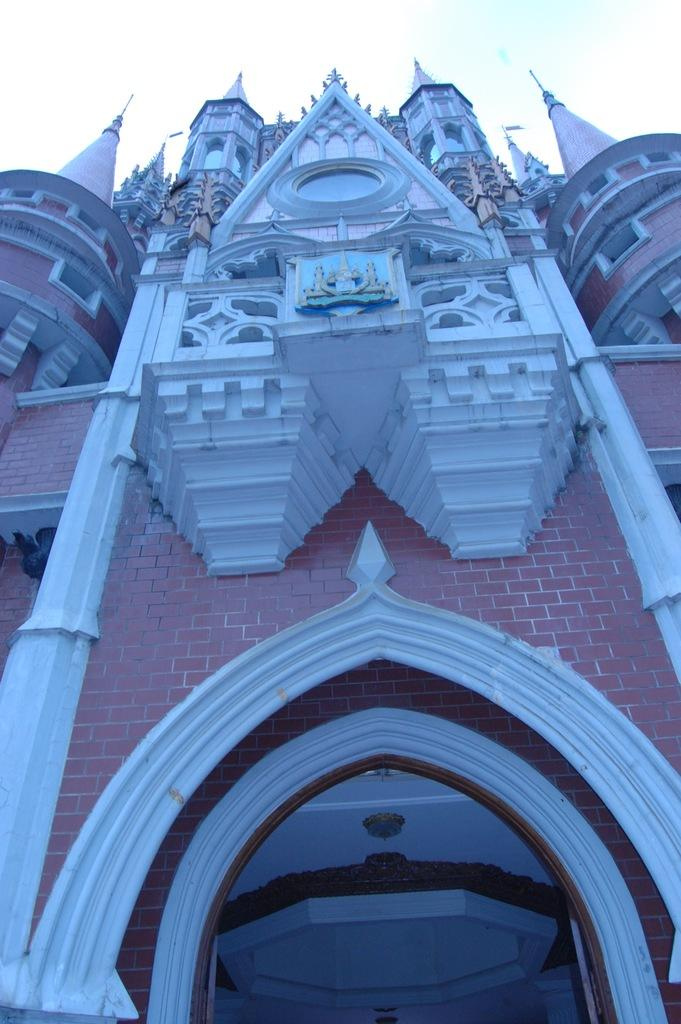What type of structure is visible in the image? There is a shrine present in the image. What is the color of the shrine? The shrine is pink in color. What type of distribution system is depicted in the image? There is no distribution system present in the image; it features a pink shrine. Can you point out the location of the gun in the image? There is no gun present in the image. 